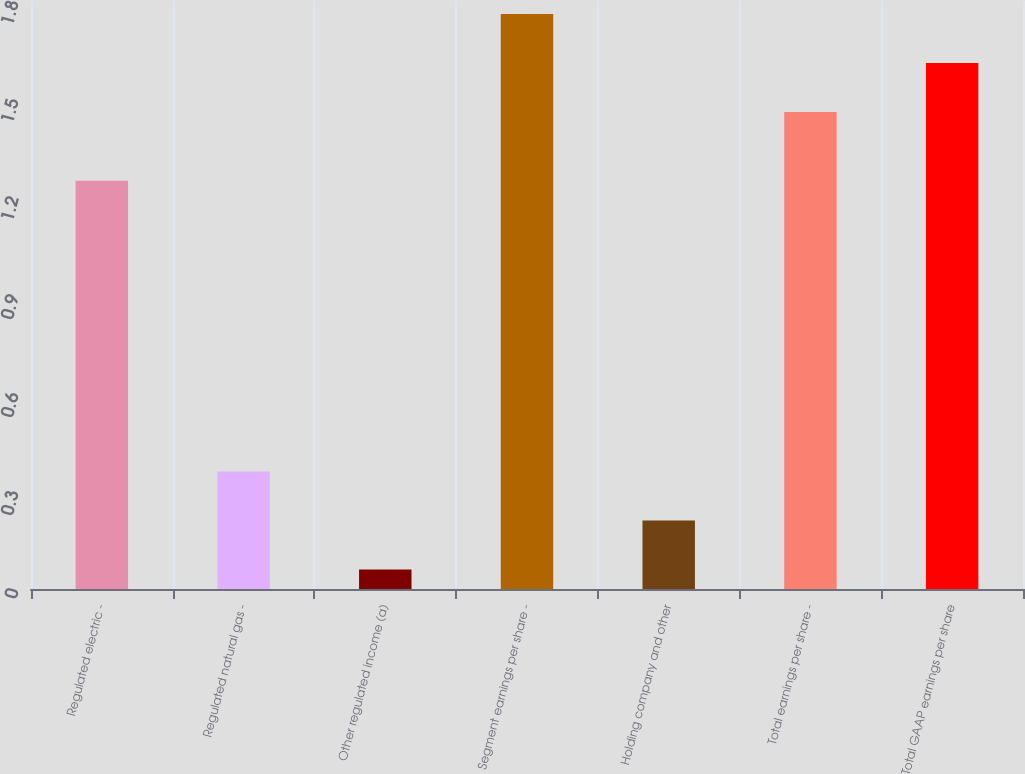Convert chart to OTSL. <chart><loc_0><loc_0><loc_500><loc_500><bar_chart><fcel>Regulated electric -<fcel>Regulated natural gas -<fcel>Other regulated income (a)<fcel>Segment earnings per share -<fcel>Holding company and other<fcel>Total earnings per share -<fcel>Total GAAP earnings per share<nl><fcel>1.25<fcel>0.36<fcel>0.06<fcel>1.76<fcel>0.21<fcel>1.46<fcel>1.61<nl></chart> 